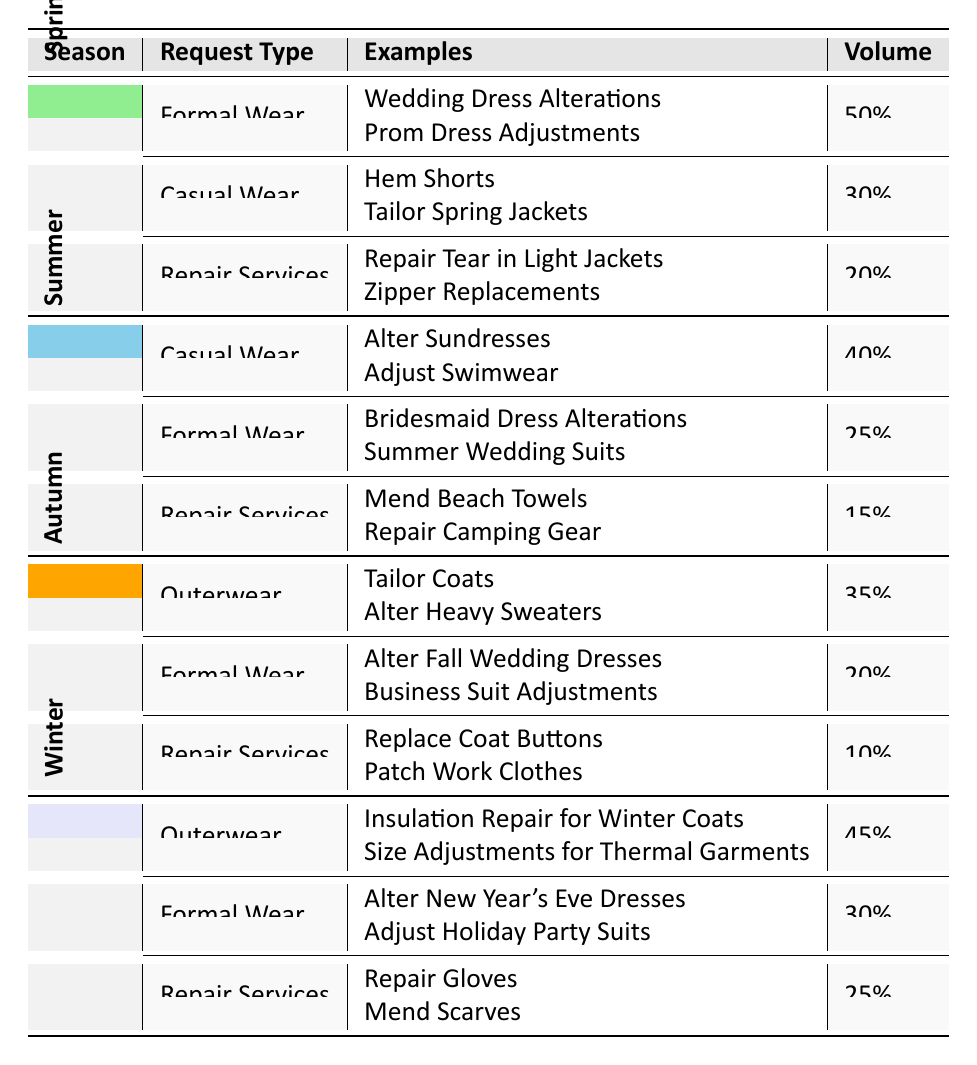What is the typical volume of formal wear requests in spring? In the spring section of the table, the typical volume for formal wear requests is listed as 50.
Answer: 50 Which season has the highest typical volume for repair services? By comparing the typical volumes for repair services across seasons, spring has 20, summer has 15, autumn has 10, and winter has 25. The highest volume is 25 in winter.
Answer: Winter Are there any casual wear requests in autumn? The autumn section of the table does not list casual wear as a request type; it shows outerwear, formal wear, and repair services only. Therefore, there are no casual wear requests in autumn.
Answer: No What is the total typical volume of requests for formal wear across all seasons? The typical volumes for formal wear are 50 in spring, 25 in summer, 20 in autumn, and 30 in winter. Adding these together gives 50 + 25 + 20 + 30 = 125.
Answer: 125 In which season is the typical volume for outerwear the highest and what is that volume? The typical volumes for outerwear are 0 in spring, 0 in summer, 35 in autumn, and 45 in winter. The highest volume is 45 in winter.
Answer: Winter, 45 What types of alterations are primarily requested in summer? In the summer section, the request types listed are casual wear (with examples like altering sundresses), formal wear, and repair services. The primary focus is casual wear, which leads with 40.
Answer: Casual wear Which request type has the least typical volume in autumn and what is that volume? The repair services in autumn have a typical volume of 10, which is the lowest among the request types in the autumn season (outerwear 35, formal wear 20).
Answer: Repair services, 10 Calculate the average typical volume of repair services across the seasons. The typical volumes for repair services are 20 in spring, 15 in summer, 10 in autumn, and 25 in winter. To find the average, sum them up: 20 + 15 + 10 + 25 = 70, then divide by 4, giving an average of 70/4 = 17.5.
Answer: 17.5 